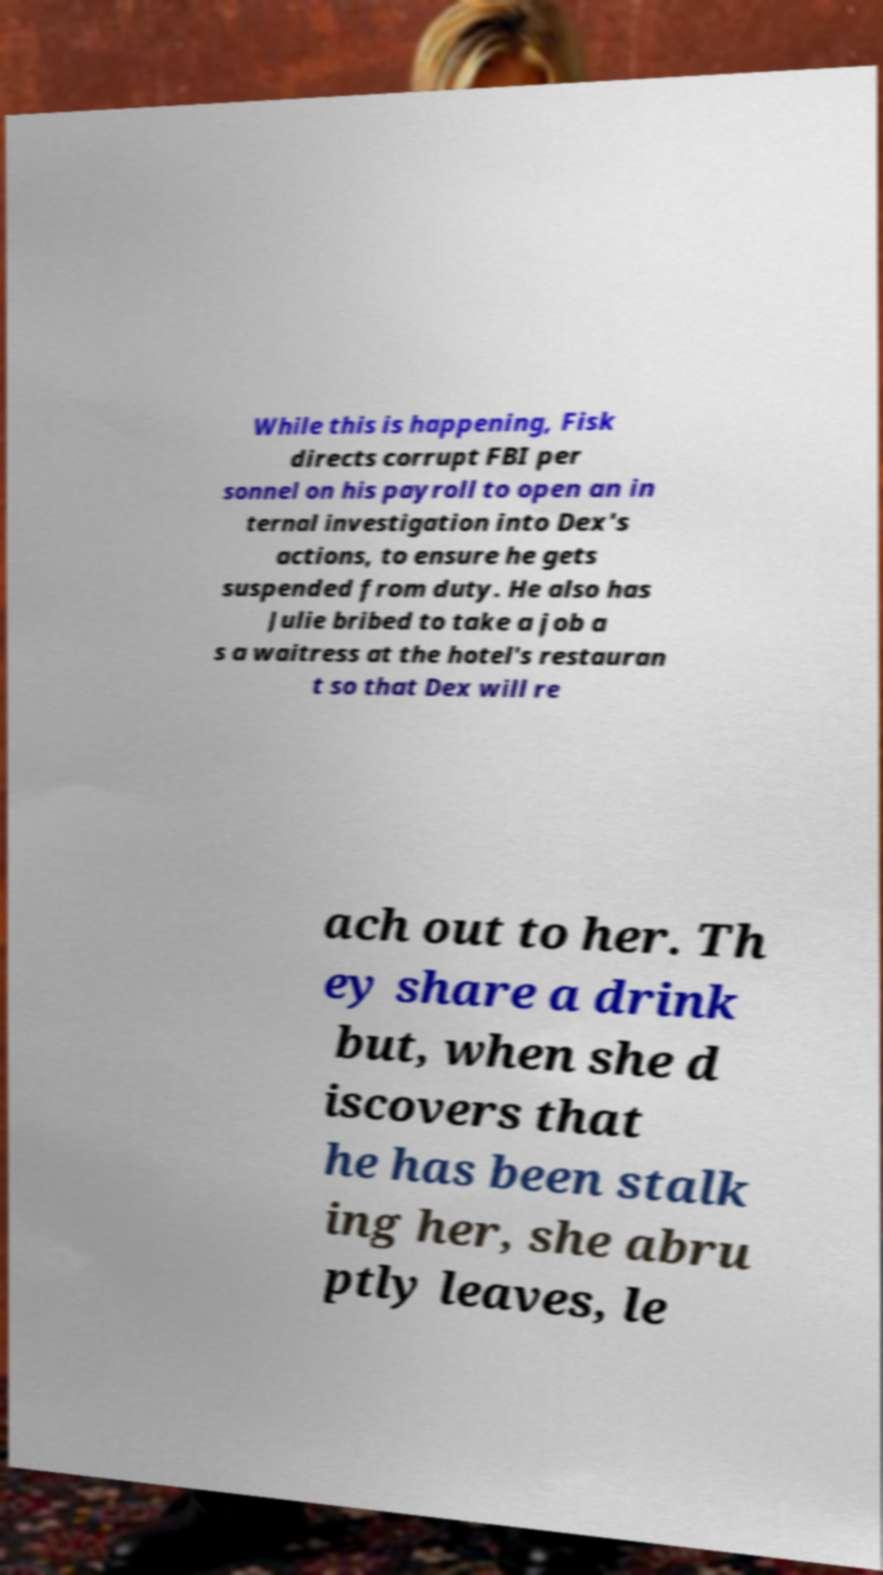Can you accurately transcribe the text from the provided image for me? While this is happening, Fisk directs corrupt FBI per sonnel on his payroll to open an in ternal investigation into Dex's actions, to ensure he gets suspended from duty. He also has Julie bribed to take a job a s a waitress at the hotel's restauran t so that Dex will re ach out to her. Th ey share a drink but, when she d iscovers that he has been stalk ing her, she abru ptly leaves, le 